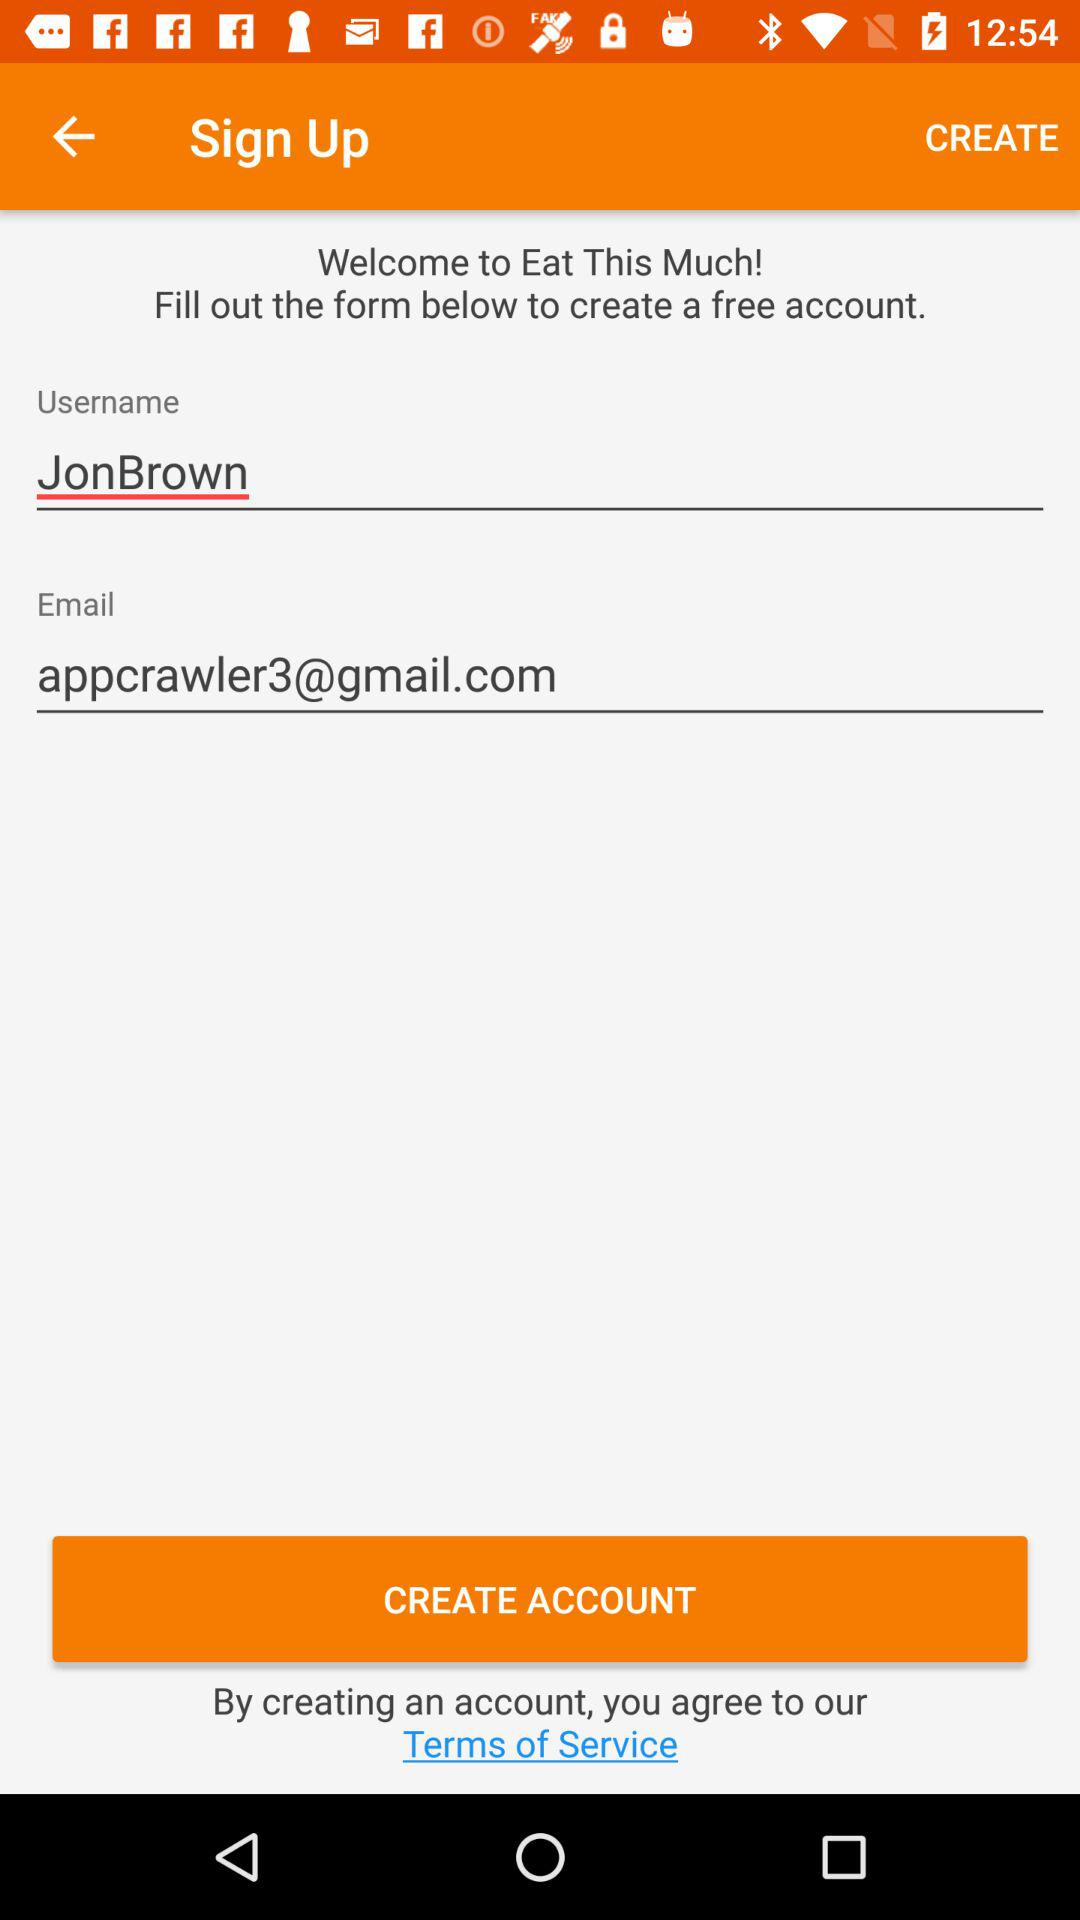What is the email address? The email address is appcrawler3@gmail.com. 